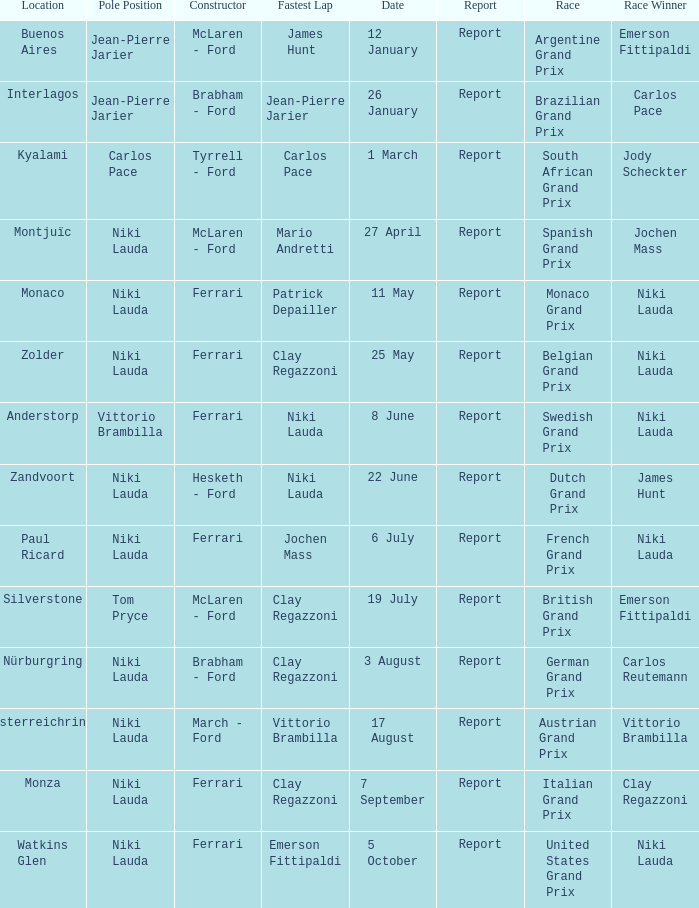Where did the team in which Tom Pryce was in Pole Position race? Silverstone. 